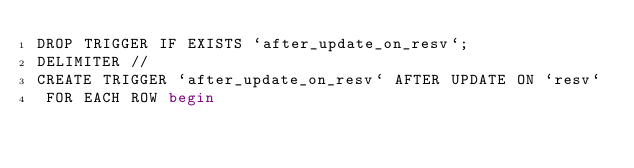Convert code to text. <code><loc_0><loc_0><loc_500><loc_500><_SQL_>DROP TRIGGER IF EXISTS `after_update_on_resv`;
DELIMITER //
CREATE TRIGGER `after_update_on_resv` AFTER UPDATE ON `resv`
 FOR EACH ROW begin</code> 